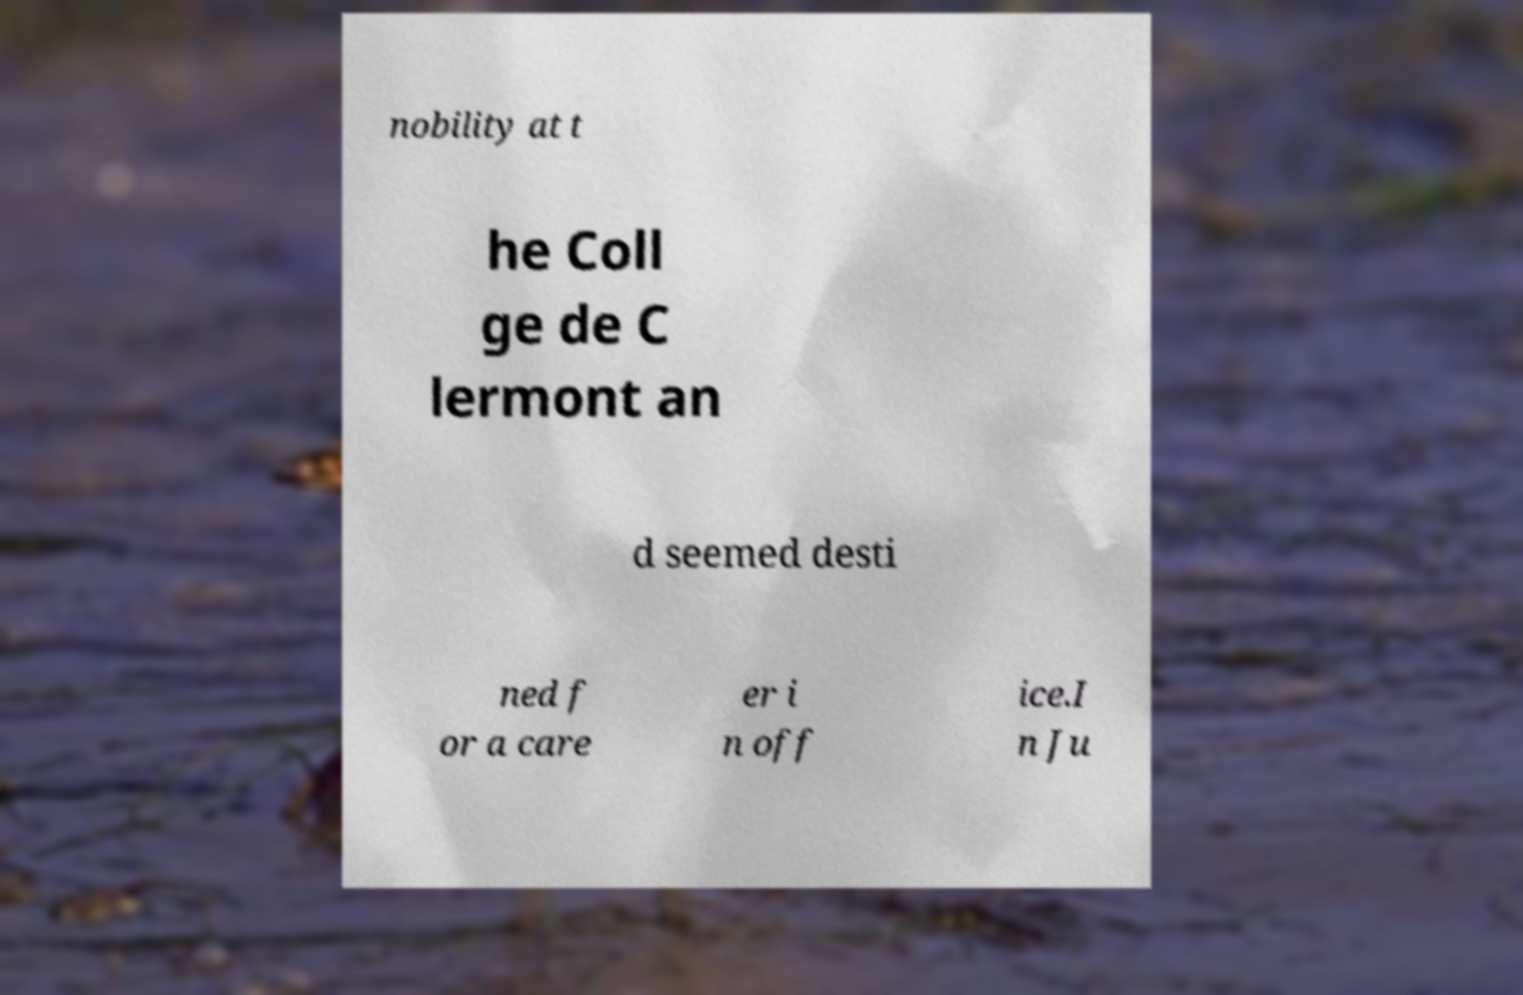Please identify and transcribe the text found in this image. nobility at t he Coll ge de C lermont an d seemed desti ned f or a care er i n off ice.I n Ju 